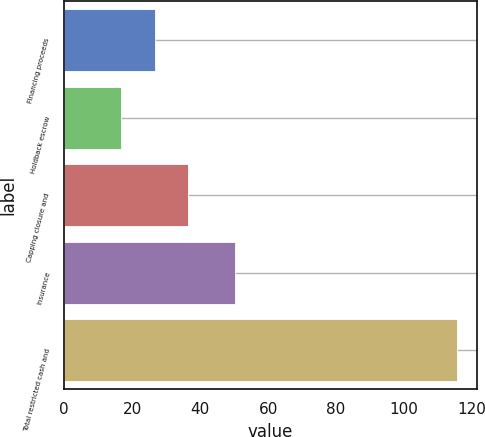Convert chart to OTSL. <chart><loc_0><loc_0><loc_500><loc_500><bar_chart><fcel>Financing proceeds<fcel>Holdback escrow<fcel>Capping closure and<fcel>Insurance<fcel>Total restricted cash and<nl><fcel>26.68<fcel>16.8<fcel>36.56<fcel>50.4<fcel>115.6<nl></chart> 